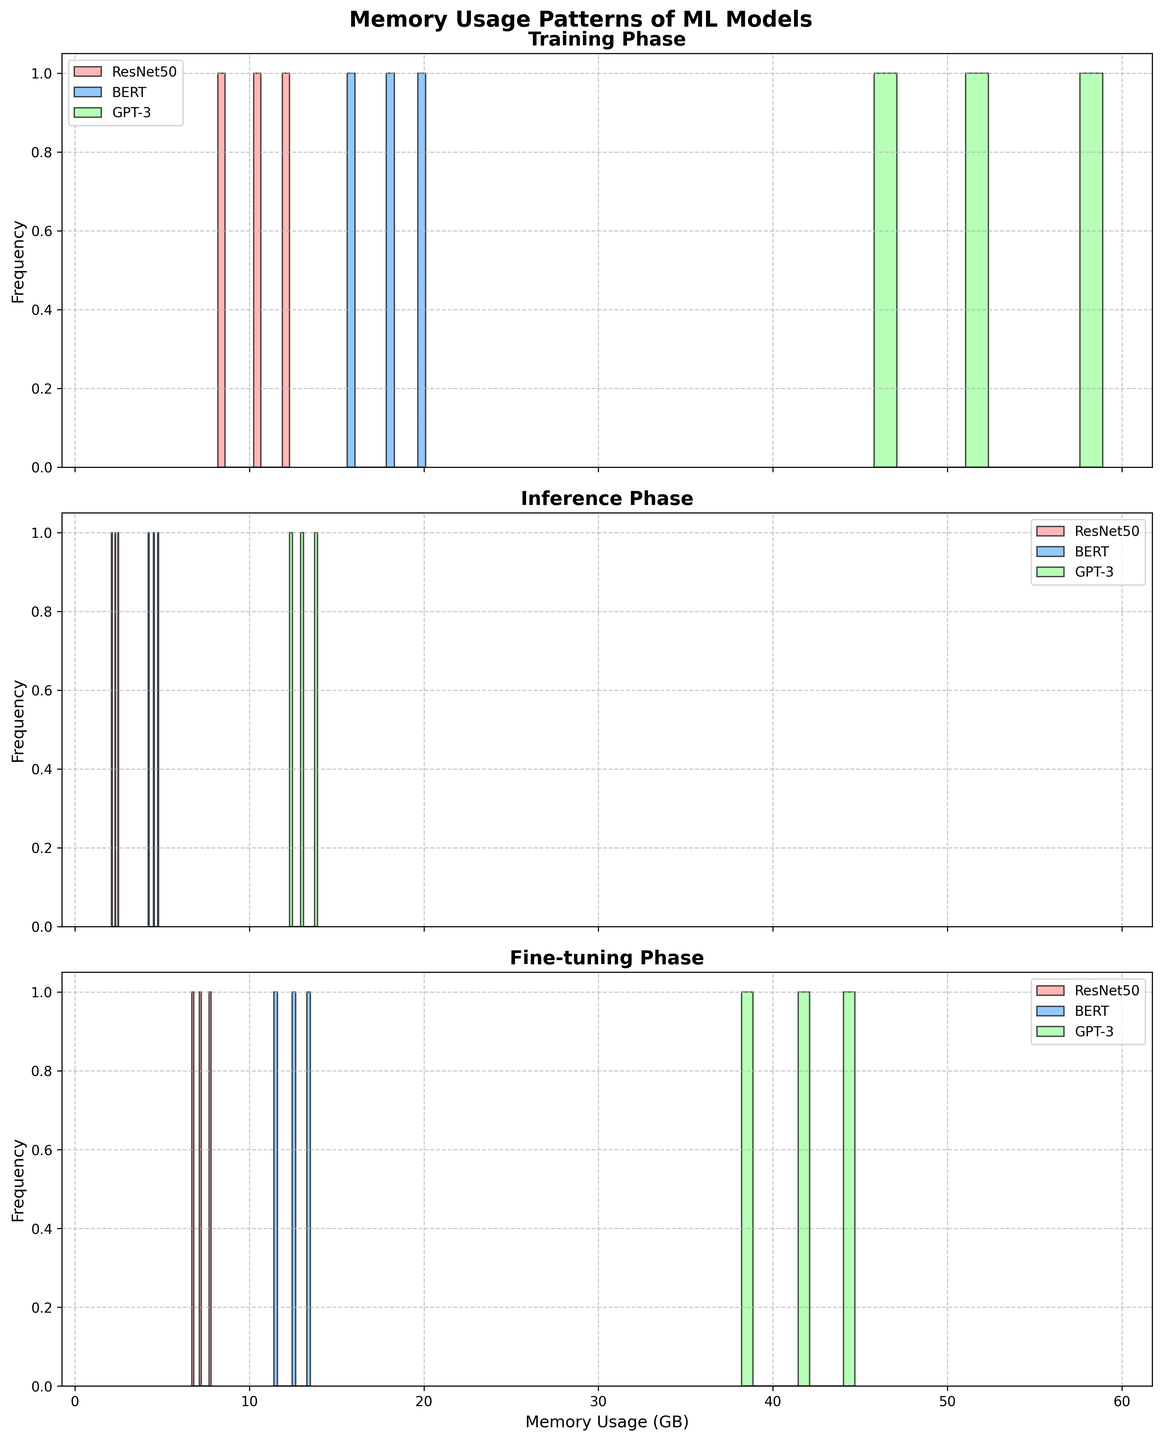What is the title of the figure? The title of the figure is displayed at the top in large, bold text.
Answer: Memory Usage Patterns of ML Models Which model has the highest memory usage during the training phase? By examining the bars in the Training Phase subplot, the GPT-3 model shows the highest memory usage.
Answer: GPT-3 Which phase shows the lowest memory usage for ResNet50? By comparing the memory usage in the three phases for ResNet50, the Inference phase exhibits the lowest memory usage.
Answer: Inference Compare the memory usage distribution between Training and Fine-tuning phases for BERT. Which one is higher on average? By observing the histograms, BERT's memory usage data in the Training phase is generally higher than in the Fine-tuning phase.
Answer: Training What is the color used for the BERT model in the histograms? The BERT model is represented using the second color, which is light blue.
Answer: Light blue How does the memory usage vary for GPT-3 between the Training and Inference phases? By comparing the histograms, GPT-3 has significantly higher memory usage during the Training phase compared to the Inference phase.
Answer: Training is higher In the Fine-tuning phase, which model appears to have the most frequent memory usage between 40 and 50 GB? By looking at the histogram bins for the Fine-tuning phase, GPT-3 shows the most frequent memory usage between 40 and 50 GB.
Answer: GPT-3 Count the number of bins for memory usage in the ResNet50 model during Inference. The histogram bins for ResNet50 during the Inference phase are divided into 10 bins.
Answer: 10 Which model has the narrowest range of memory usage during the Training phase? By observing the spread of the histograms, ResNet50 has the narrowest range of memory usage during the Training phase.
Answer: ResNet50 